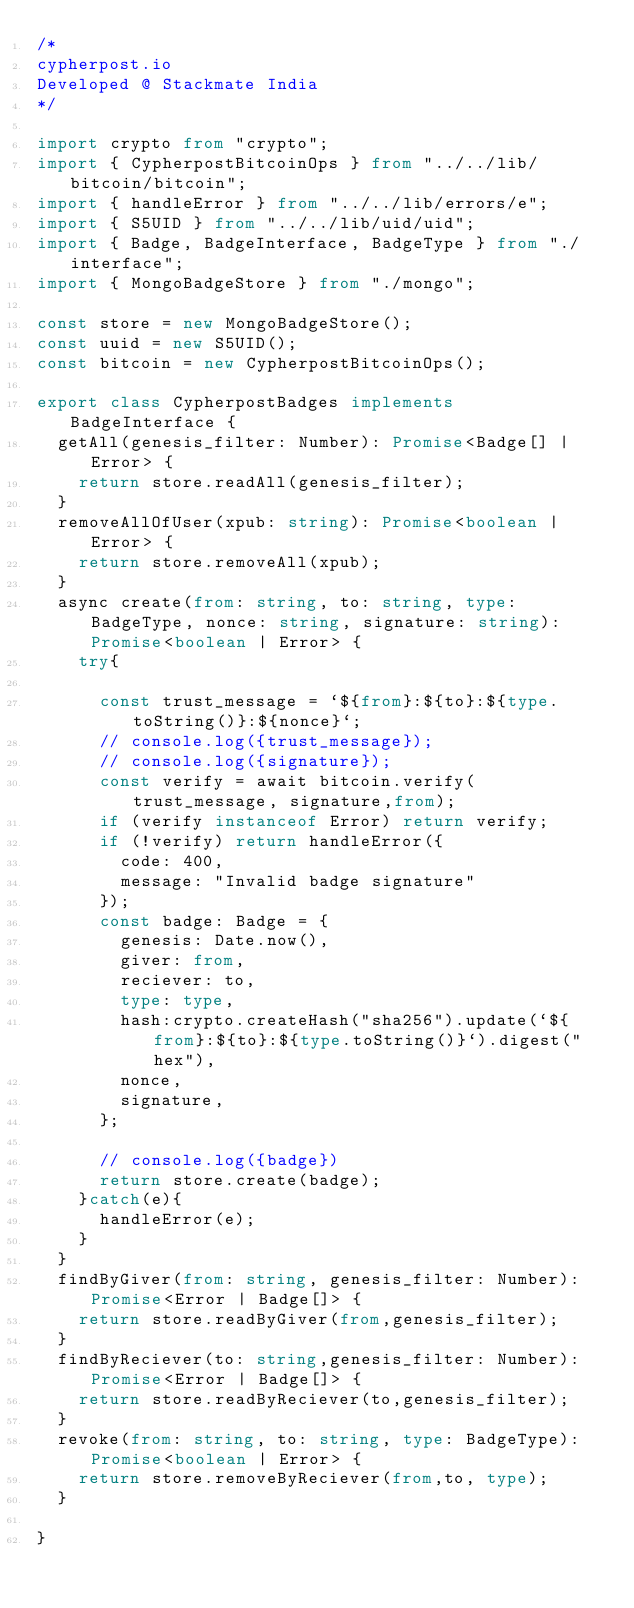Convert code to text. <code><loc_0><loc_0><loc_500><loc_500><_TypeScript_>/*
cypherpost.io
Developed @ Stackmate India
*/

import crypto from "crypto";
import { CypherpostBitcoinOps } from "../../lib/bitcoin/bitcoin";
import { handleError } from "../../lib/errors/e";
import { S5UID } from "../../lib/uid/uid";
import { Badge, BadgeInterface, BadgeType } from "./interface";
import { MongoBadgeStore } from "./mongo";

const store = new MongoBadgeStore();
const uuid = new S5UID();
const bitcoin = new CypherpostBitcoinOps();

export class CypherpostBadges implements BadgeInterface {
  getAll(genesis_filter: Number): Promise<Badge[] | Error> {
    return store.readAll(genesis_filter);
  }
  removeAllOfUser(xpub: string): Promise<boolean | Error> {
    return store.removeAll(xpub);
  }
  async create(from: string, to: string, type: BadgeType, nonce: string, signature: string): Promise<boolean | Error> {
    try{
  
      const trust_message = `${from}:${to}:${type.toString()}:${nonce}`;
      // console.log({trust_message});
      // console.log({signature});
      const verify = await bitcoin.verify(trust_message, signature,from);
      if (verify instanceof Error) return verify;
      if (!verify) return handleError({
        code: 400,
        message: "Invalid badge signature"
      });
      const badge: Badge = {
        genesis: Date.now(),
        giver: from,
        reciever: to,
        type: type,
        hash:crypto.createHash("sha256").update(`${from}:${to}:${type.toString()}`).digest("hex"),
        nonce,
        signature,
      };

      // console.log({badge})
      return store.create(badge);
    }catch(e){
      handleError(e);
    }
  }
  findByGiver(from: string, genesis_filter: Number): Promise<Error | Badge[]> {
    return store.readByGiver(from,genesis_filter);
  }
  findByReciever(to: string,genesis_filter: Number): Promise<Error | Badge[]> {
    return store.readByReciever(to,genesis_filter);
  }
  revoke(from: string, to: string, type: BadgeType): Promise<boolean | Error> {
    return store.removeByReciever(from,to, type);
  }

}</code> 